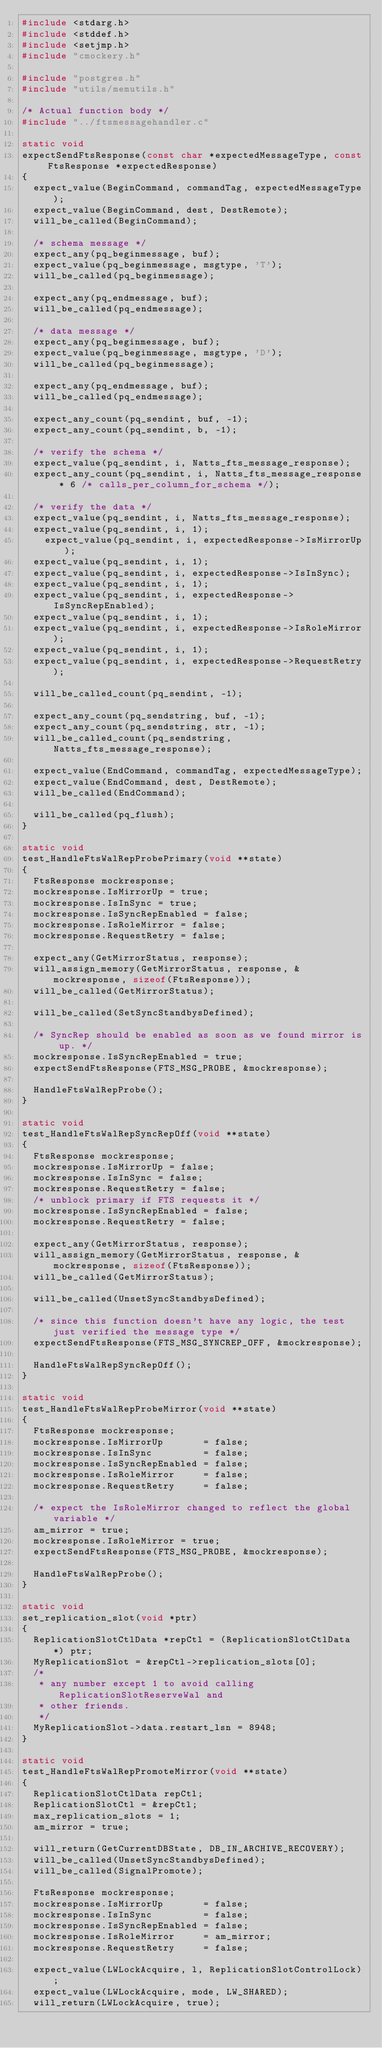<code> <loc_0><loc_0><loc_500><loc_500><_C_>#include <stdarg.h>
#include <stddef.h>
#include <setjmp.h>
#include "cmockery.h"

#include "postgres.h"
#include "utils/memutils.h"

/* Actual function body */
#include "../ftsmessagehandler.c"

static void
expectSendFtsResponse(const char *expectedMessageType, const FtsResponse *expectedResponse)
{
	expect_value(BeginCommand, commandTag, expectedMessageType);
	expect_value(BeginCommand, dest, DestRemote);
	will_be_called(BeginCommand);

	/* schema message */
	expect_any(pq_beginmessage, buf);
	expect_value(pq_beginmessage, msgtype, 'T');
	will_be_called(pq_beginmessage);

	expect_any(pq_endmessage, buf);
	will_be_called(pq_endmessage);

	/* data message */
	expect_any(pq_beginmessage, buf);
	expect_value(pq_beginmessage, msgtype, 'D');
	will_be_called(pq_beginmessage);

	expect_any(pq_endmessage, buf);
	will_be_called(pq_endmessage);

	expect_any_count(pq_sendint, buf, -1);
	expect_any_count(pq_sendint, b, -1);

	/* verify the schema */
	expect_value(pq_sendint, i, Natts_fts_message_response);
	expect_any_count(pq_sendint, i, Natts_fts_message_response * 6 /* calls_per_column_for_schema */);

	/* verify the data */
	expect_value(pq_sendint, i, Natts_fts_message_response);
	expect_value(pq_sendint, i, 1);
  	expect_value(pq_sendint, i, expectedResponse->IsMirrorUp);
	expect_value(pq_sendint, i, 1);
	expect_value(pq_sendint, i, expectedResponse->IsInSync);
	expect_value(pq_sendint, i, 1);
	expect_value(pq_sendint, i, expectedResponse->IsSyncRepEnabled);
	expect_value(pq_sendint, i, 1);
	expect_value(pq_sendint, i, expectedResponse->IsRoleMirror);
	expect_value(pq_sendint, i, 1);
	expect_value(pq_sendint, i, expectedResponse->RequestRetry);

	will_be_called_count(pq_sendint, -1);

	expect_any_count(pq_sendstring, buf, -1);
	expect_any_count(pq_sendstring, str, -1);
	will_be_called_count(pq_sendstring, Natts_fts_message_response);

	expect_value(EndCommand, commandTag, expectedMessageType);
	expect_value(EndCommand, dest, DestRemote);
	will_be_called(EndCommand);

	will_be_called(pq_flush);
}

static void
test_HandleFtsWalRepProbePrimary(void **state)
{
	FtsResponse mockresponse;
	mockresponse.IsMirrorUp = true;
	mockresponse.IsInSync = true;
	mockresponse.IsSyncRepEnabled = false;
	mockresponse.IsRoleMirror = false;
	mockresponse.RequestRetry = false;

	expect_any(GetMirrorStatus, response);
	will_assign_memory(GetMirrorStatus, response, &mockresponse, sizeof(FtsResponse));
	will_be_called(GetMirrorStatus);

	will_be_called(SetSyncStandbysDefined);

	/* SyncRep should be enabled as soon as we found mirror is up. */
	mockresponse.IsSyncRepEnabled = true;
	expectSendFtsResponse(FTS_MSG_PROBE, &mockresponse);

	HandleFtsWalRepProbe();
}

static void
test_HandleFtsWalRepSyncRepOff(void **state)
{
	FtsResponse mockresponse;
	mockresponse.IsMirrorUp = false;
	mockresponse.IsInSync = false;
	mockresponse.RequestRetry = false;
	/* unblock primary if FTS requests it */
	mockresponse.IsSyncRepEnabled = false;
	mockresponse.RequestRetry = false;

	expect_any(GetMirrorStatus, response);
	will_assign_memory(GetMirrorStatus, response, &mockresponse, sizeof(FtsResponse));
	will_be_called(GetMirrorStatus);

	will_be_called(UnsetSyncStandbysDefined);

	/* since this function doesn't have any logic, the test just verified the message type */
	expectSendFtsResponse(FTS_MSG_SYNCREP_OFF, &mockresponse);
	
	HandleFtsWalRepSyncRepOff();
}

static void
test_HandleFtsWalRepProbeMirror(void **state)
{
	FtsResponse mockresponse;
	mockresponse.IsMirrorUp       = false;
	mockresponse.IsInSync         = false;
	mockresponse.IsSyncRepEnabled = false;
	mockresponse.IsRoleMirror     = false;
	mockresponse.RequestRetry     = false;

	/* expect the IsRoleMirror changed to reflect the global variable */
	am_mirror = true;
	mockresponse.IsRoleMirror = true;
	expectSendFtsResponse(FTS_MSG_PROBE, &mockresponse);

	HandleFtsWalRepProbe();
}

static void
set_replication_slot(void *ptr)
{
	ReplicationSlotCtlData *repCtl = (ReplicationSlotCtlData *) ptr;
	MyReplicationSlot = &repCtl->replication_slots[0];
	/*
	 * any number except 1 to avoid calling ReplicationSlotReserveWal and
	 * other friends.
	 */
	MyReplicationSlot->data.restart_lsn = 8948;
}

static void
test_HandleFtsWalRepPromoteMirror(void **state)
{
	ReplicationSlotCtlData repCtl;
	ReplicationSlotCtl = &repCtl;
	max_replication_slots = 1;
	am_mirror = true;

	will_return(GetCurrentDBState, DB_IN_ARCHIVE_RECOVERY);
	will_be_called(UnsetSyncStandbysDefined);
	will_be_called(SignalPromote);

	FtsResponse mockresponse;
	mockresponse.IsMirrorUp       = false;
	mockresponse.IsInSync         = false;
	mockresponse.IsSyncRepEnabled = false;
	mockresponse.IsRoleMirror     = am_mirror;
	mockresponse.RequestRetry     = false;

	expect_value(LWLockAcquire, l, ReplicationSlotControlLock);
	expect_value(LWLockAcquire, mode, LW_SHARED);
	will_return(LWLockAcquire, true);
</code> 